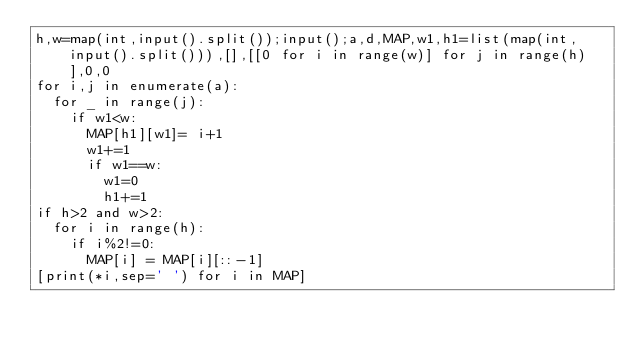<code> <loc_0><loc_0><loc_500><loc_500><_Python_>h,w=map(int,input().split());input();a,d,MAP,w1,h1=list(map(int,input().split())),[],[[0 for i in range(w)] for j in range(h)],0,0
for i,j in enumerate(a):
  for _ in range(j):
    if w1<w:
      MAP[h1][w1]= i+1
      w1+=1
      if w1==w:
        w1=0
        h1+=1
if h>2 and w>2:
  for i in range(h):
    if i%2!=0:
      MAP[i] = MAP[i][::-1]
[print(*i,sep=' ') for i in MAP]</code> 